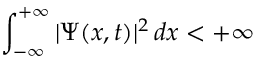<formula> <loc_0><loc_0><loc_500><loc_500>\int _ { - \infty } ^ { + \infty } | \Psi ( x , t ) | ^ { 2 } \, d x < + \infty</formula> 